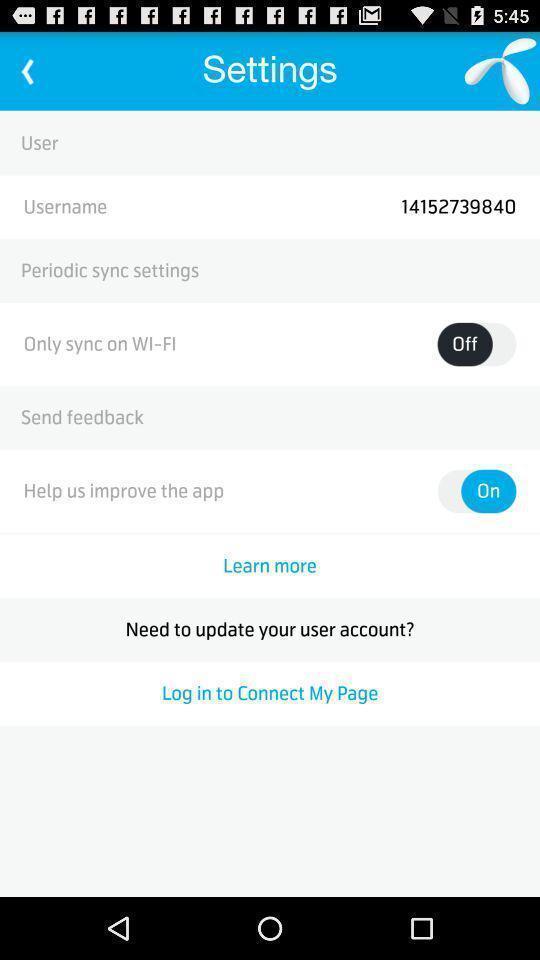Describe this image in words. Settings page of contacts application. 